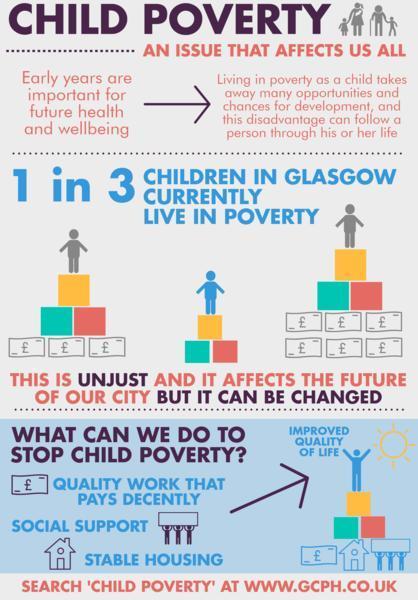What percent of children in Glasgow currently live in poverty?
Answer the question with a short phrase. 33.33% How many factors are listed as a solution to stop child poverty? 3 